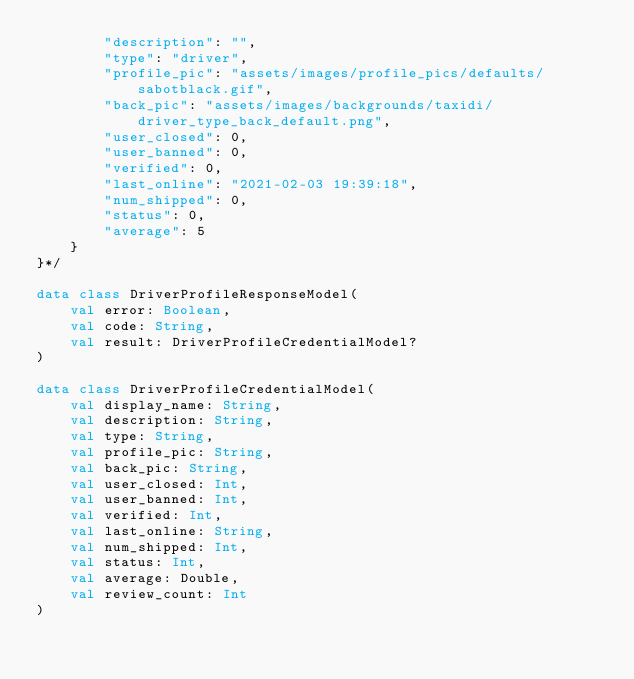<code> <loc_0><loc_0><loc_500><loc_500><_Kotlin_>        "description": "",
        "type": "driver",
        "profile_pic": "assets/images/profile_pics/defaults/sabotblack.gif",
        "back_pic": "assets/images/backgrounds/taxidi/driver_type_back_default.png",
        "user_closed": 0,
        "user_banned": 0,
        "verified": 0,
        "last_online": "2021-02-03 19:39:18",
        "num_shipped": 0,
        "status": 0,
        "average": 5
    }
}*/

data class DriverProfileResponseModel(
    val error: Boolean,
    val code: String,
    val result: DriverProfileCredentialModel?
)

data class DriverProfileCredentialModel(
    val display_name: String,
    val description: String,
    val type: String,
    val profile_pic: String,
    val back_pic: String,
    val user_closed: Int,
    val user_banned: Int,
    val verified: Int,
    val last_online: String,
    val num_shipped: Int,
    val status: Int,
    val average: Double,
    val review_count: Int
)
</code> 